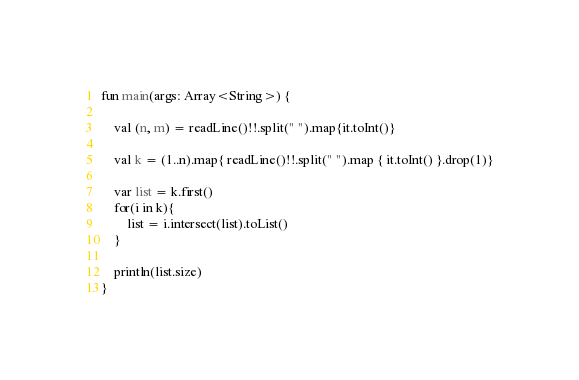Convert code to text. <code><loc_0><loc_0><loc_500><loc_500><_Kotlin_>fun main(args: Array<String>) {

    val (n, m) = readLine()!!.split(" ").map{it.toInt()}

    val k = (1..n).map{ readLine()!!.split(" ").map { it.toInt() }.drop(1)}

    var list = k.first()
    for(i in k){
        list = i.intersect(list).toList()
    }

    println(list.size)
}
</code> 